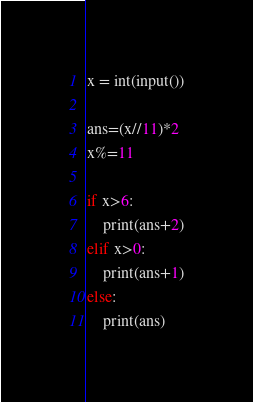Convert code to text. <code><loc_0><loc_0><loc_500><loc_500><_Python_>x = int(input())

ans=(x//11)*2
x%=11

if x>6:
    print(ans+2)
elif x>0:
    print(ans+1)
else:
    print(ans)</code> 